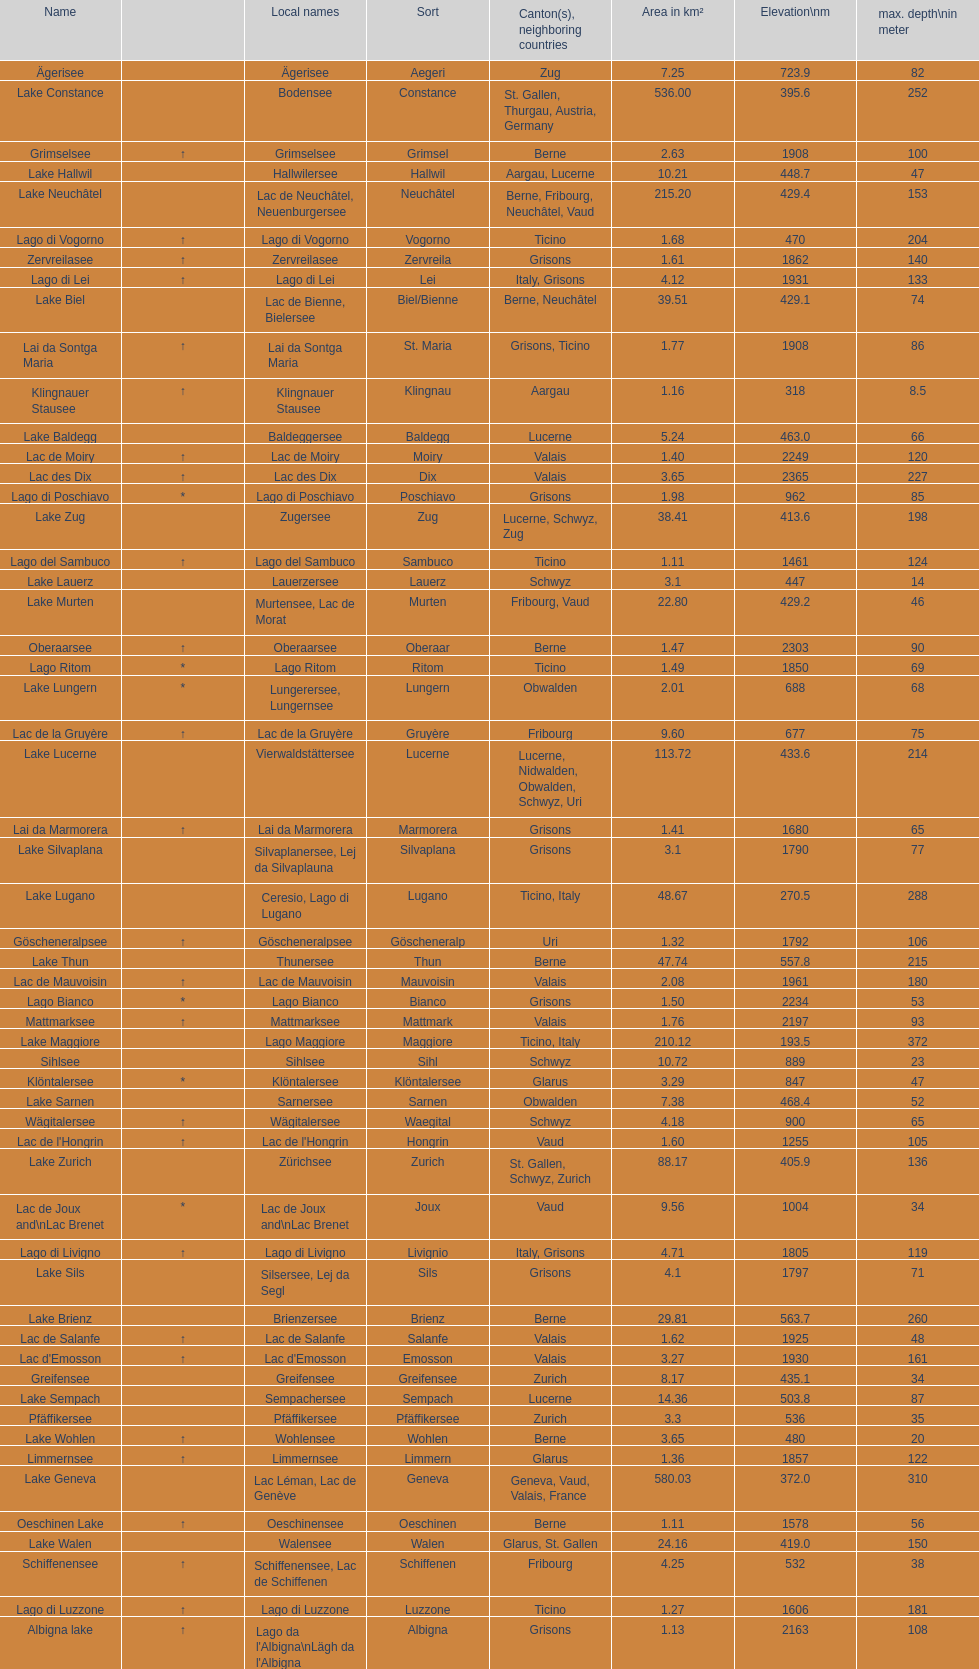Which lake is situated at the highest altitude? Lac des Dix. 